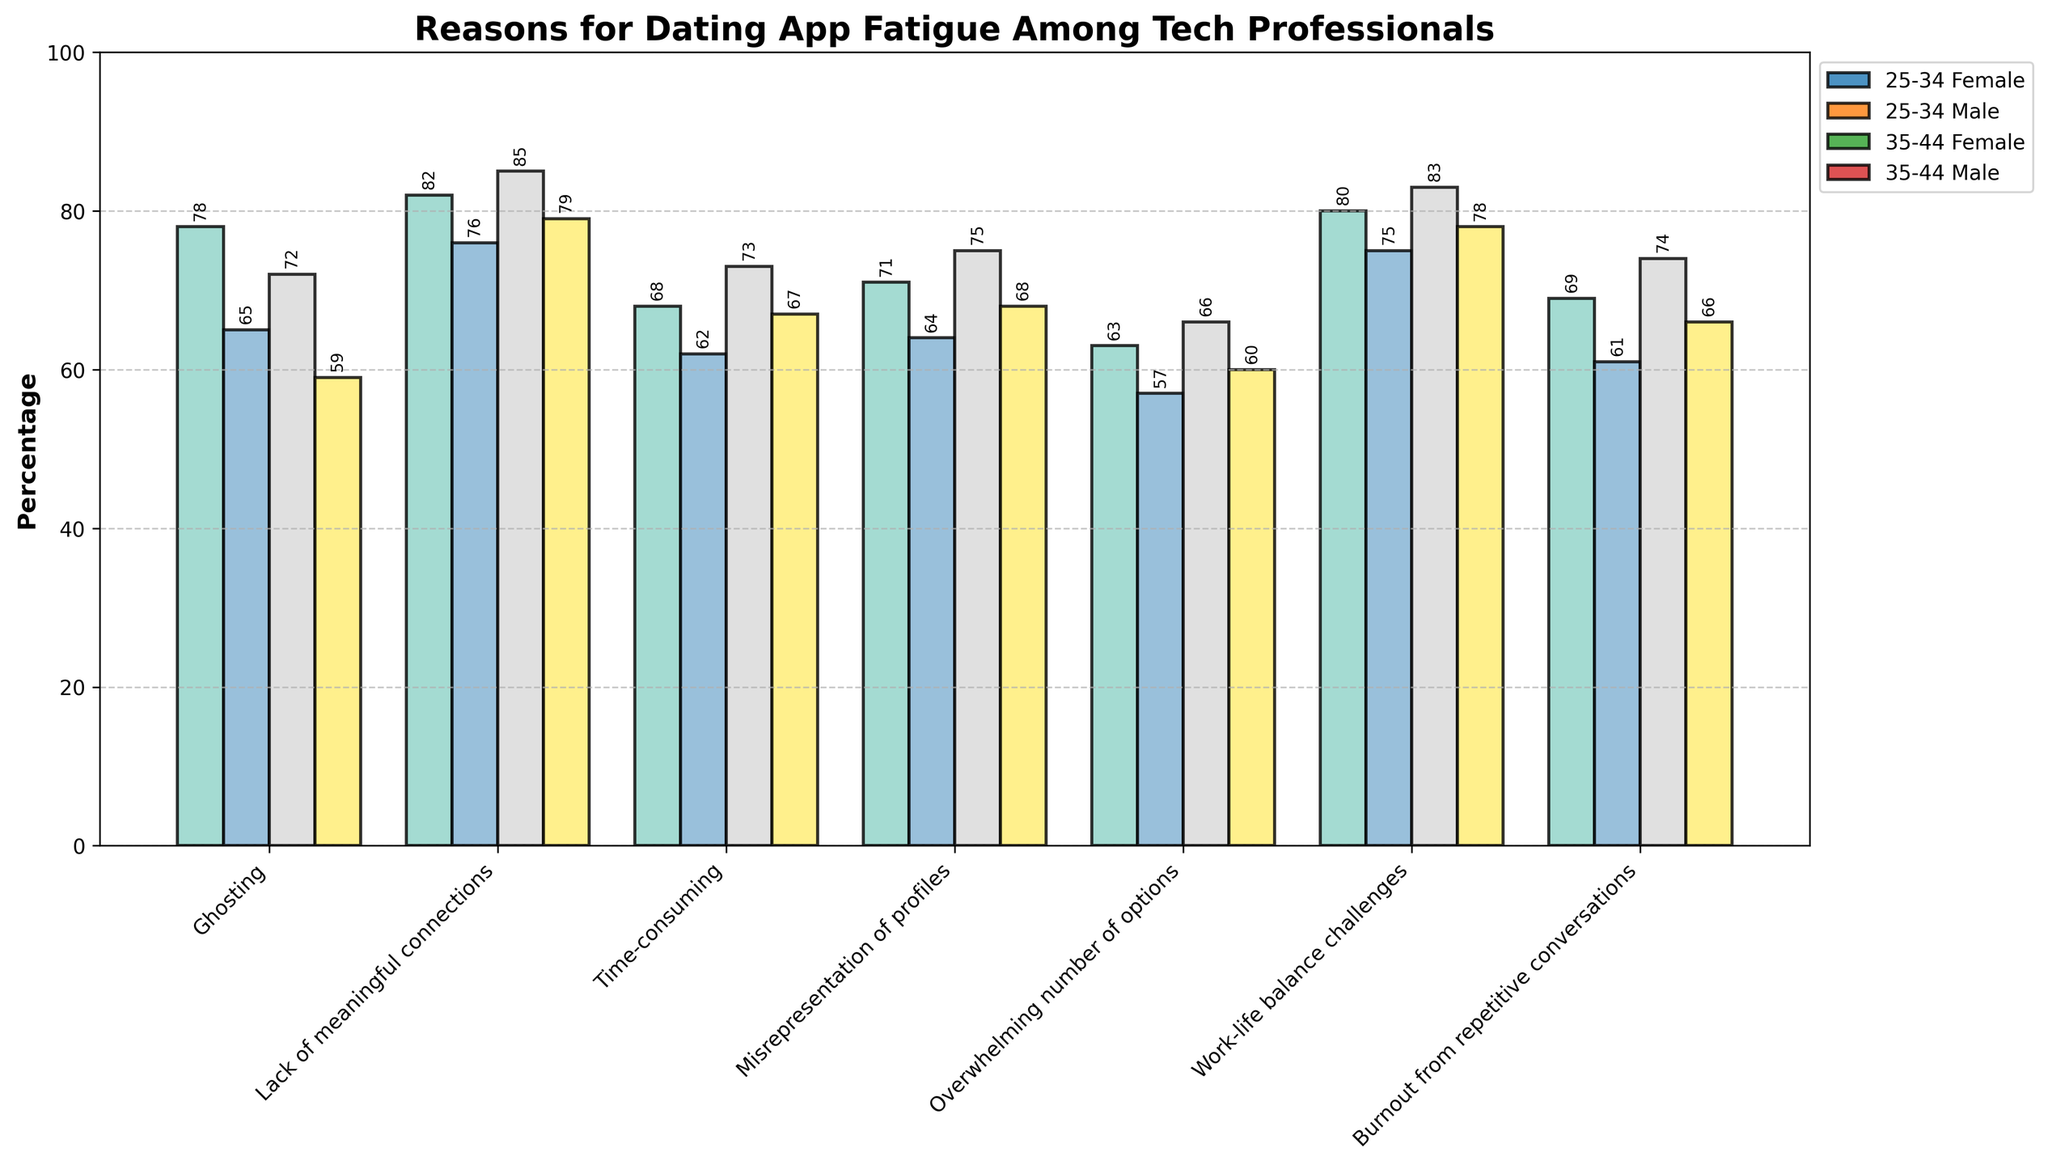What's the most common reason for dating app fatigue among 25-34 year-old females? Look at the bars for the 25-34 age range and the Female gender. The highest percentage bar corresponds to the reason ‘Lack of meaningful connections’ at 82%.
Answer: Lack of meaningful connections Which reason has the smallest gender difference in the 35-44 age range? Compare the percentage differences between male and female for all reasons in the 35-44 age range. The smallest difference is for 'Overwhelming number of options' with Female (66%) and Male (60%), a difference of 6 percentage points.
Answer: Overwhelming number of options What's the percentage difference in "Ghosting" between 35-44 year-old males and females? Check the "Ghosting" percentage for 35-44 age range: Females have 72% and Males have 59%. The difference is 72% - 59%, which equals 13%.
Answer: 13% If combining both age groups, do more females or males report "Time-consuming" as a reason for dating app fatigue? Sum the percentages for "Time-consuming" for both age groups in both genders. Females: (68% + 73%) = 141%, Males: (62% + 67%) = 129%. Females have a higher total percentage.
Answer: Females What is the average percentage of "Misrepresentation of profiles" among all groups? Calculate the average by summing the percentages for "Misrepresentation of profiles" across all groups and dividing by the number of groups: (71% + 64% + 75% + 68%) / 4 groups = 69.5%.
Answer: 69.5% Which reason has the highest percentage for 25-34 year-old males? Find the highest bar for the 25-34 age range and Male gender. The highest percentage corresponds to 'Lack of meaningful connections' at 76%.
Answer: Lack of meaningful connections Is the percentage of "Burnout from repetitive conversations" higher in females or males for the 35-44 age range? Look at the bars for the 35-44 age range under the reason "Burnout from repetitive conversations". Females have 74% and Males have 66%. Females have a higher percentage.
Answer: Females What's the total percentage response for “Work-life balance challenges” across all the groups? Sum the percentages for all groups on "Work-life balance challenges": 80% + 75% + 83% + 78% = 316%.
Answer: 316% How do the percentages for "Overwhelming number of options" compare between 25-34 year-old females and males? Check the bars for "Overwhelming number of options" in the 25-34 age group. Females have 63% and Males have 57%. Females have a higher percentage.
Answer: Females What's the difference in percentage points for "Time-consuming" between the average of all females and all males across age ranges? Calculate the averages: Females (68% + 73%) / 2 = 70.5%, Males (62% + 67%) / 2 = 64.5%. The difference is 70.5% - 64.5% = 6%.
Answer: 6% 